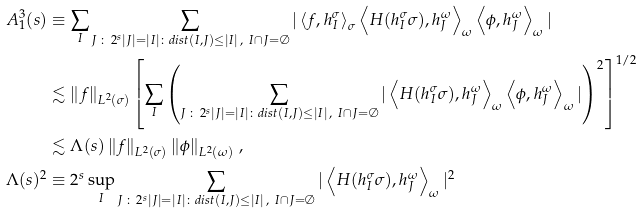<formula> <loc_0><loc_0><loc_500><loc_500>A _ { 1 } ^ { 3 } ( s ) & \equiv \sum _ { I } \sum _ { J \, \colon \, 2 ^ { s } | J | = | I | \colon d i s t ( I , J ) \leq | I | \, , \ I \cap J = \emptyset } | \left \langle f , h _ { I } ^ { \sigma } \right \rangle _ { \sigma } \left \langle H ( h _ { I } ^ { \sigma } \sigma ) , h _ { J } ^ { \omega } \right \rangle _ { \omega } \left \langle \phi , h _ { J } ^ { \omega } \right \rangle _ { \omega } | \\ & \lesssim \left \| f \right \| _ { L ^ { 2 } ( \sigma ) } \left [ \sum _ { I } \left ( \sum _ { J \, \colon \, 2 ^ { s } | J | = | I | \colon d i s t ( I , J ) \leq | I | \, , \ I \cap J = \emptyset } | \left \langle H ( h _ { I } ^ { \sigma } \sigma ) , h _ { J } ^ { \omega } \right \rangle _ { \omega } \left \langle \phi , h _ { J } ^ { \omega } \right \rangle _ { \omega } | \right ) ^ { 2 } \right ] ^ { 1 / 2 } \\ & \lesssim \Lambda ( s ) \left \| f \right \| _ { L ^ { 2 } ( \sigma ) } \left \| \phi \right \| _ { L ^ { 2 } ( \omega ) } \, , \\ \Lambda ( s ) ^ { 2 } & \equiv 2 ^ { s } \sup _ { I } \sum _ { J \, \colon \, 2 ^ { s } | J | = | I | \colon d i s t ( I , J ) \leq | I | \, , \ I \cap J = \emptyset } | \left \langle H ( h _ { I } ^ { \sigma } \sigma ) , h _ { J } ^ { \omega } \right \rangle _ { \omega } | ^ { 2 }</formula> 